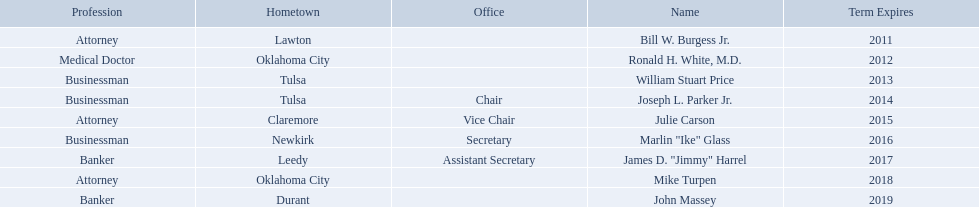What are all the names of oklahoma state regents for higher educations? Bill W. Burgess Jr., Ronald H. White, M.D., William Stuart Price, Joseph L. Parker Jr., Julie Carson, Marlin "Ike" Glass, James D. "Jimmy" Harrel, Mike Turpen, John Massey. Help me parse the entirety of this table. {'header': ['Profession', 'Hometown', 'Office', 'Name', 'Term Expires'], 'rows': [['Attorney', 'Lawton', '', 'Bill W. Burgess Jr.', '2011'], ['Medical Doctor', 'Oklahoma City', '', 'Ronald H. White, M.D.', '2012'], ['Businessman', 'Tulsa', '', 'William Stuart Price', '2013'], ['Businessman', 'Tulsa', 'Chair', 'Joseph L. Parker Jr.', '2014'], ['Attorney', 'Claremore', 'Vice Chair', 'Julie Carson', '2015'], ['Businessman', 'Newkirk', 'Secretary', 'Marlin "Ike" Glass', '2016'], ['Banker', 'Leedy', 'Assistant Secretary', 'James D. "Jimmy" Harrel', '2017'], ['Attorney', 'Oklahoma City', '', 'Mike Turpen', '2018'], ['Banker', 'Durant', '', 'John Massey', '2019']]} Which ones are businessmen? William Stuart Price, Joseph L. Parker Jr., Marlin "Ike" Glass. Of those, who is from tulsa? William Stuart Price, Joseph L. Parker Jr. Whose term expires in 2014? Joseph L. Parker Jr. Can you give me this table as a dict? {'header': ['Profession', 'Hometown', 'Office', 'Name', 'Term Expires'], 'rows': [['Attorney', 'Lawton', '', 'Bill W. Burgess Jr.', '2011'], ['Medical Doctor', 'Oklahoma City', '', 'Ronald H. White, M.D.', '2012'], ['Businessman', 'Tulsa', '', 'William Stuart Price', '2013'], ['Businessman', 'Tulsa', 'Chair', 'Joseph L. Parker Jr.', '2014'], ['Attorney', 'Claremore', 'Vice Chair', 'Julie Carson', '2015'], ['Businessman', 'Newkirk', 'Secretary', 'Marlin "Ike" Glass', '2016'], ['Banker', 'Leedy', 'Assistant Secretary', 'James D. "Jimmy" Harrel', '2017'], ['Attorney', 'Oklahoma City', '', 'Mike Turpen', '2018'], ['Banker', 'Durant', '', 'John Massey', '2019']]} What are all of the names? Bill W. Burgess Jr., Ronald H. White, M.D., William Stuart Price, Joseph L. Parker Jr., Julie Carson, Marlin "Ike" Glass, James D. "Jimmy" Harrel, Mike Turpen, John Massey. Where is each member from? Lawton, Oklahoma City, Tulsa, Tulsa, Claremore, Newkirk, Leedy, Oklahoma City, Durant. Along with joseph l. parker jr., which other member is from tulsa? William Stuart Price. 